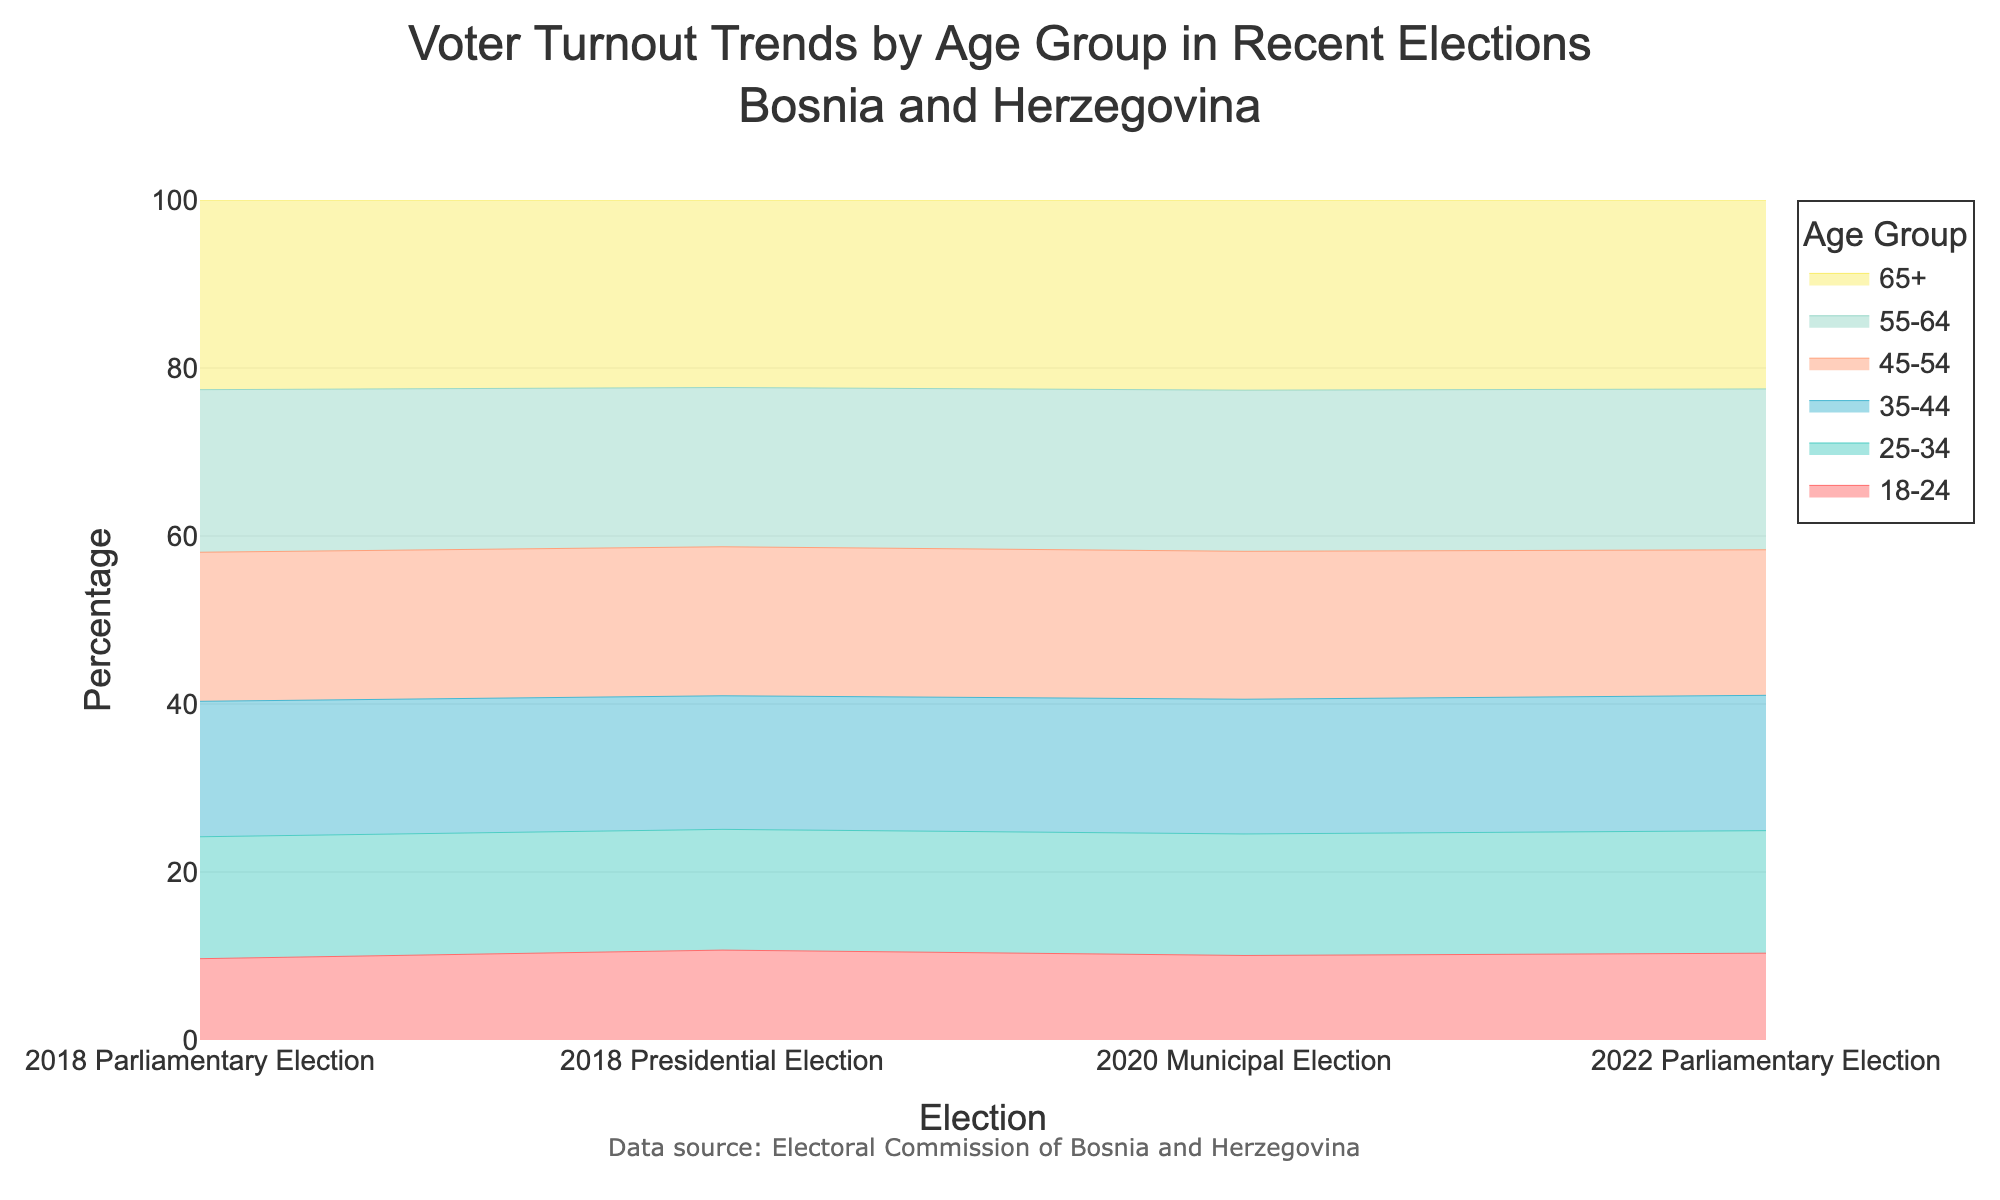What is the title of the figure? The title of a figure is usually at the top and provides a brief description of what the figure is about. For this figure, the title reads "Voter Turnout Trends by Age Group in Recent Elections<br>Bosnia and Herzegovina".
Answer: Voter Turnout Trends by Age Group in Recent Elections Bosnia and Herzegovina Which age group had the highest voter turnout in all elections? By looking at the stream graph, the age group at the top of each column (the stacked line chart for each election) represents the highest value. The 65+ age group is always at the top.
Answer: 65+ What is the difference in voter turnout between the 18-24 and 65+ age groups in the 2018 Parliamentary Election? Identify the values for the 18-24 age group (30%) and 65+ age group (70%) in the 2018 Parliamentary Election data. Subtract the first from the second (70% - 30% = 40%).
Answer: 40% How does the voter turnout of the 35-44 age group change from the 2018 Parliamentary Election to the 2022 Parliamentary Election? Look at the percentages for the 35-44 age group in both elections: 50% in 2018 and 53% in 2022. The change is calculated by (53% - 50% = 3%).
Answer: 3% What can you infer about the voter turnout trend for the 45-54 age group between all the elections? Observe the trend for the 45-54 age group across all elections: 55% in 2018 Parliamentary, 58% in 2018 Presidential, 56% in 2020 Municipal, and 57% in 2022 Parliamentary. The trend shows slight fluctuations but generally remains around the high 50s.
Answer: Slight fluctuations, generally around high 50s Which age group shows the smallest increase in voter turnout from the 2018 Parliamentary to the 2022 Parliamentary elections? Calculate the increase for each age group by subtracting the 2018 value from the 2022 value and find the smallest difference. The 18-24 age group goes from 34% to 30%, an increase of 4%, which is the smallest among all age groups.
Answer: 18-24 What were the overall trends observed in voter turnout across all age groups and elections? Examining the entire graph shows that elder age groups consistently have higher voter turnout, while younger age groups have comparatively lower turnout. Slight increases are observed in older age groups over the elections.
Answer: Elder groups consistent higher, younger lower, slight increase in older Which age group had the closest voter turnout percentage to 50% in the 2018 Presidential Election? Find the 2018 Presidential Election column and look for the age group closest to 50%. The 35-44 age group has 52%, which is the closest value to 50%.
Answer: 35-44 